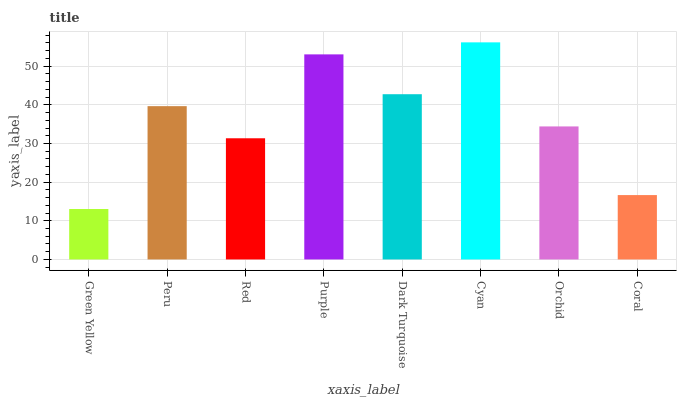Is Peru the minimum?
Answer yes or no. No. Is Peru the maximum?
Answer yes or no. No. Is Peru greater than Green Yellow?
Answer yes or no. Yes. Is Green Yellow less than Peru?
Answer yes or no. Yes. Is Green Yellow greater than Peru?
Answer yes or no. No. Is Peru less than Green Yellow?
Answer yes or no. No. Is Peru the high median?
Answer yes or no. Yes. Is Orchid the low median?
Answer yes or no. Yes. Is Green Yellow the high median?
Answer yes or no. No. Is Cyan the low median?
Answer yes or no. No. 